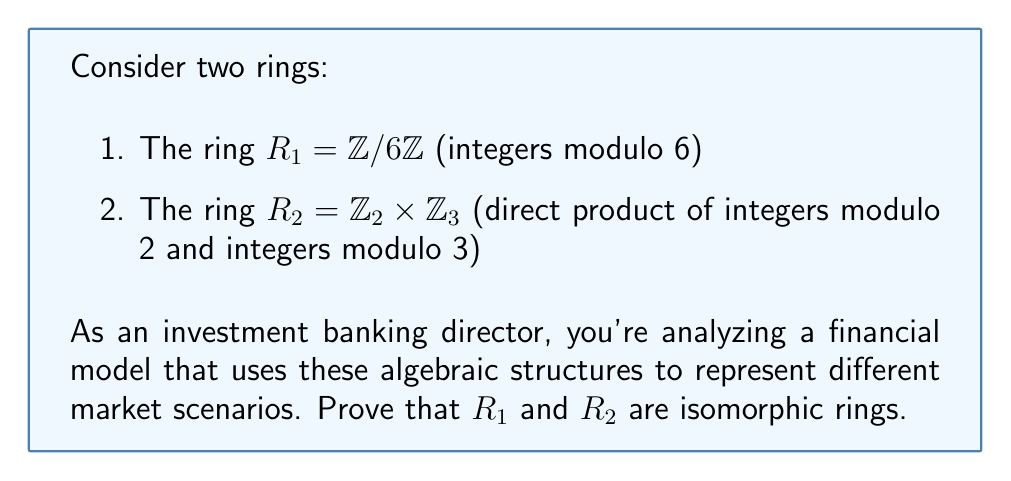Show me your answer to this math problem. To prove that $R_1$ and $R_2$ are isomorphic, we need to construct a bijective ring homomorphism $\phi: R_1 \rightarrow R_2$. Let's proceed step-by-step:

1) First, let's define the mapping $\phi$:
   $$\phi: \mathbb{Z}/6\mathbb{Z} \rightarrow \mathbb{Z}_2 \times \mathbb{Z}_3$$
   $$\phi([x]_6) = ([x]_2, [x]_3)$$

2) We need to prove that $\phi$ is well-defined, bijective, and preserves both addition and multiplication.

3) Well-defined: If $[x]_6 = [y]_6$, then $x \equiv y \pmod{6}$. This implies $x \equiv y \pmod{2}$ and $x \equiv y \pmod{3}$. Therefore, $([x]_2, [x]_3) = ([y]_2, [y]_3)$.

4) Bijective:
   - Injective: If $\phi([x]_6) = \phi([y]_6)$, then $([x]_2, [x]_3) = ([y]_2, [y]_3)$. This means $x \equiv y \pmod{2}$ and $x \equiv y \pmod{3}$. By the Chinese Remainder Theorem, $x \equiv y \pmod{6}$, so $[x]_6 = [y]_6$.
   - Surjective: For any $([a]_2, [b]_3) \in \mathbb{Z}_2 \times \mathbb{Z}_3$, there exists $[x]_6 \in \mathbb{Z}/6\mathbb{Z}$ such that $x \equiv a \pmod{2}$ and $x \equiv b \pmod{3}$ (again by the Chinese Remainder Theorem).

5) Preserves addition:
   $$\phi([x]_6 + [y]_6) = \phi([x+y]_6) = ([x+y]_2, [x+y]_3)$$
   $$= ([x]_2 + [y]_2, [x]_3 + [y]_3) = \phi([x]_6) + \phi([y]_6)$$

6) Preserves multiplication:
   $$\phi([x]_6 \cdot [y]_6) = \phi([xy]_6) = ([xy]_2, [xy]_3)$$
   $$= ([x]_2 \cdot [y]_2, [x]_3 \cdot [y]_3) = \phi([x]_6) \cdot \phi([y]_6)$$

7) Therefore, $\phi$ is a ring isomorphism between $R_1$ and $R_2$.
Answer: $R_1 \cong R_2$ via $\phi([x]_6) = ([x]_2, [x]_3)$ 